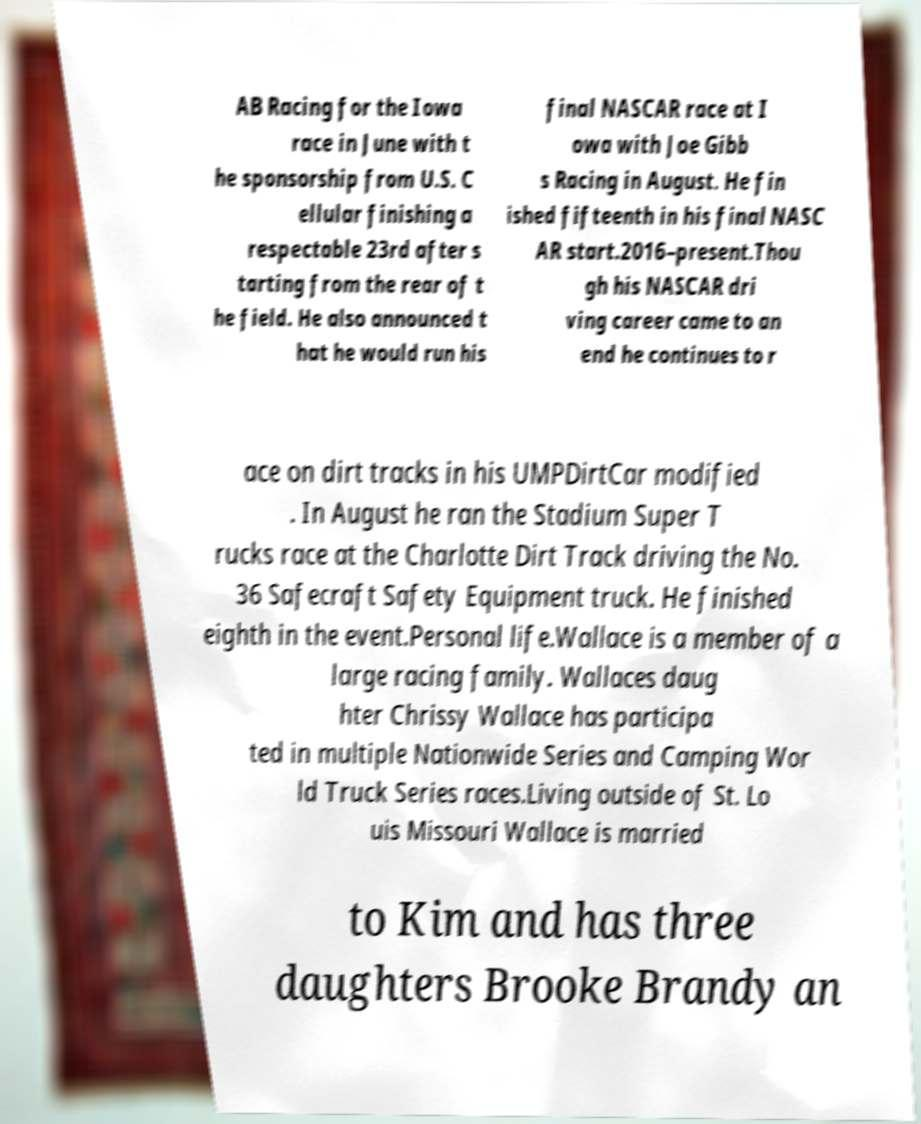There's text embedded in this image that I need extracted. Can you transcribe it verbatim? AB Racing for the Iowa race in June with t he sponsorship from U.S. C ellular finishing a respectable 23rd after s tarting from the rear of t he field. He also announced t hat he would run his final NASCAR race at I owa with Joe Gibb s Racing in August. He fin ished fifteenth in his final NASC AR start.2016–present.Thou gh his NASCAR dri ving career came to an end he continues to r ace on dirt tracks in his UMPDirtCar modified . In August he ran the Stadium Super T rucks race at the Charlotte Dirt Track driving the No. 36 Safecraft Safety Equipment truck. He finished eighth in the event.Personal life.Wallace is a member of a large racing family. Wallaces daug hter Chrissy Wallace has participa ted in multiple Nationwide Series and Camping Wor ld Truck Series races.Living outside of St. Lo uis Missouri Wallace is married to Kim and has three daughters Brooke Brandy an 